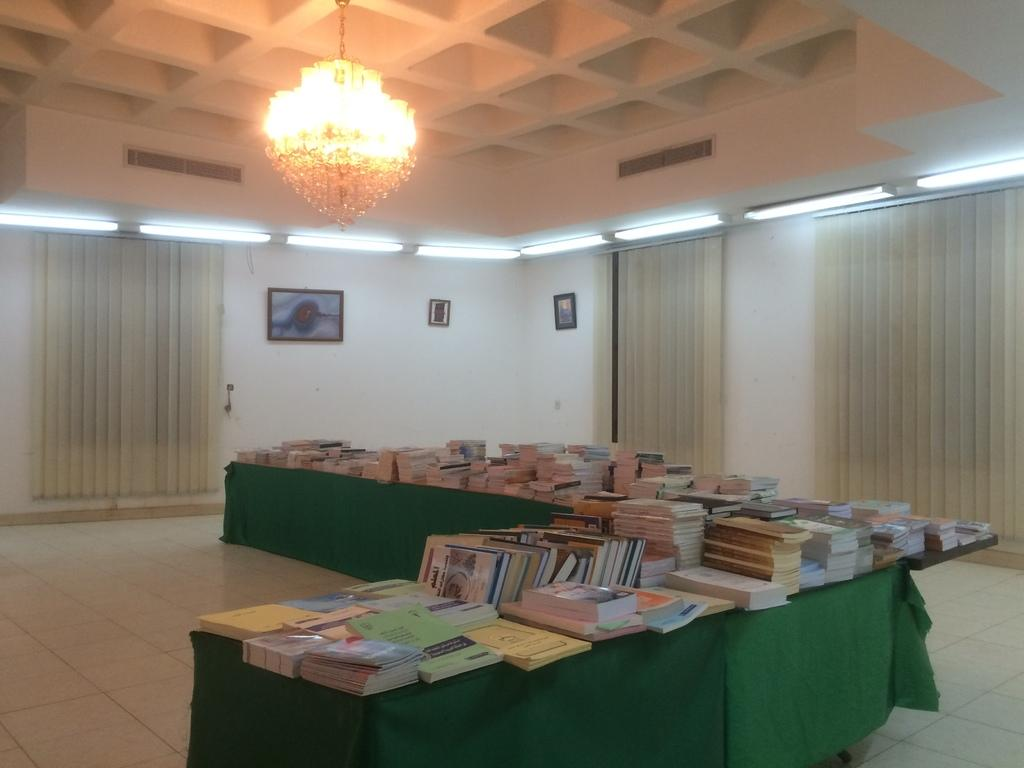What objects are placed on the table in the image? There are books placed on a table in the image. What can be seen on the wall in the image? There are photo frames on the wall in the image. What type of window treatment is present in the image? There are curtains in the image. What type of lighting fixture is hanging from the ceiling in the image? There is a chandelier hanging from the ceiling in the image. What word is written on the chandelier in the image? There is no word written on the chandelier in the image; it is a lighting fixture. What is the aftermath of the argument that took place in the room in the image? There is no mention of an argument or its aftermath in the image; it only shows books, photo frames, curtains, and a chandelier. 